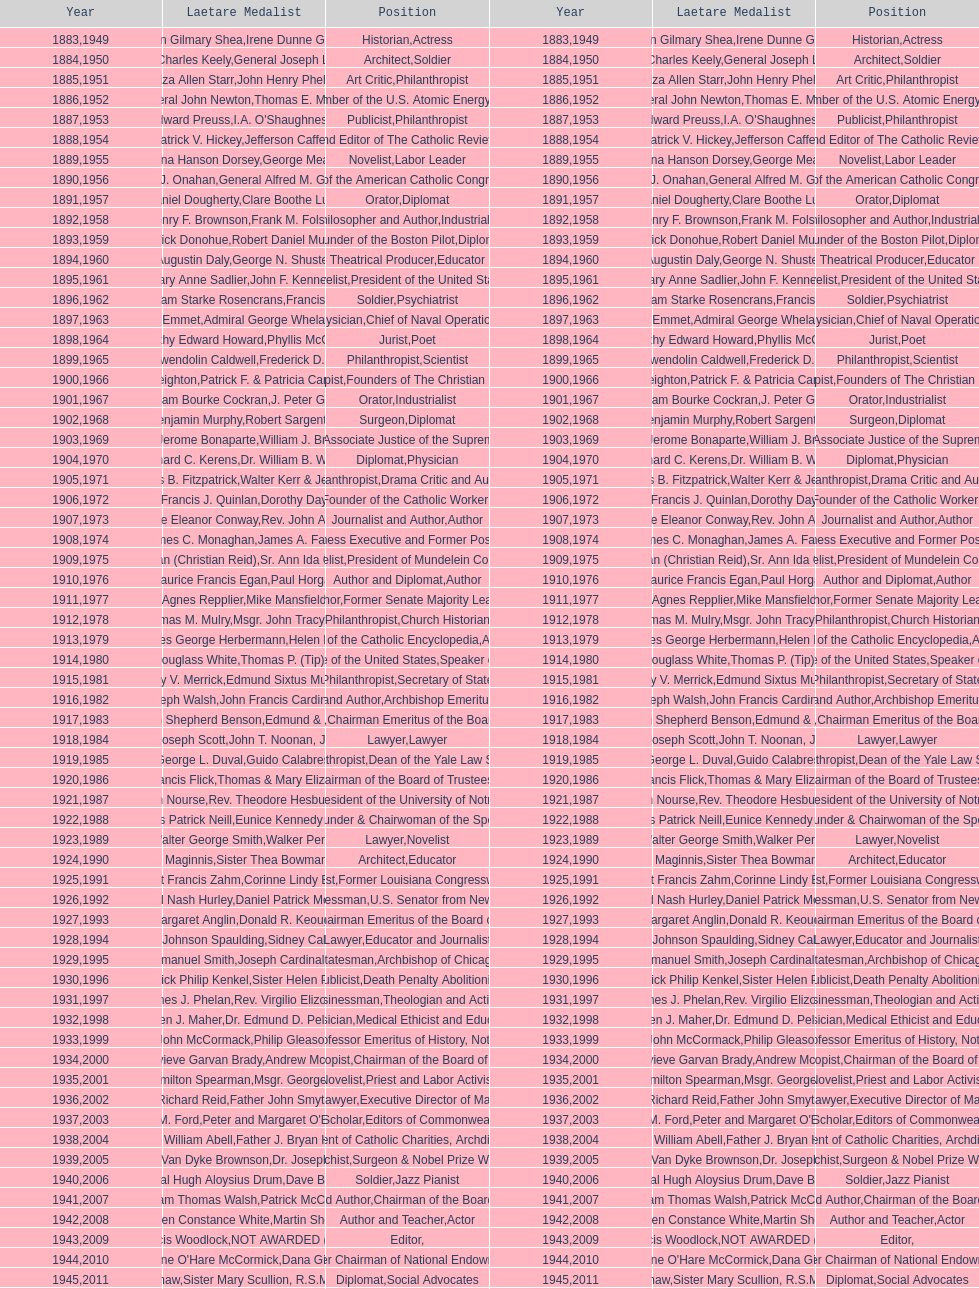Parse the full table. {'header': ['Year', 'Laetare Medalist', 'Position', 'Year', 'Laetare Medalist', 'Position'], 'rows': [['1883', 'John Gilmary Shea', 'Historian', '1949', 'Irene Dunne Griffin', 'Actress'], ['1884', 'Patrick Charles Keely', 'Architect', '1950', 'General Joseph L. Collins', 'Soldier'], ['1885', 'Eliza Allen Starr', 'Art Critic', '1951', 'John Henry Phelan', 'Philanthropist'], ['1886', 'General John Newton', 'Engineer', '1952', 'Thomas E. Murray', 'Member of the U.S. Atomic Energy Commission'], ['1887', 'Edward Preuss', 'Publicist', '1953', "I.A. O'Shaughnessy", 'Philanthropist'], ['1888', 'Patrick V. Hickey', 'Founder and Editor of The Catholic Review', '1954', 'Jefferson Caffery', 'Diplomat'], ['1889', 'Anna Hanson Dorsey', 'Novelist', '1955', 'George Meany', 'Labor Leader'], ['1890', 'William J. Onahan', 'Organizer of the American Catholic Congress', '1956', 'General Alfred M. Gruenther', 'Soldier'], ['1891', 'Daniel Dougherty', 'Orator', '1957', 'Clare Boothe Luce', 'Diplomat'], ['1892', 'Henry F. Brownson', 'Philosopher and Author', '1958', 'Frank M. Folsom', 'Industrialist'], ['1893', 'Patrick Donohue', 'Founder of the Boston Pilot', '1959', 'Robert Daniel Murphy', 'Diplomat'], ['1894', 'Augustin Daly', 'Theatrical Producer', '1960', 'George N. Shuster', 'Educator'], ['1895', 'Mary Anne Sadlier', 'Novelist', '1961', 'John F. Kennedy', 'President of the United States'], ['1896', 'General William Starke Rosencrans', 'Soldier', '1962', 'Francis J. Braceland', 'Psychiatrist'], ['1897', 'Thomas Addis Emmet', 'Physician', '1963', 'Admiral George Whelan Anderson, Jr.', 'Chief of Naval Operations'], ['1898', 'Timothy Edward Howard', 'Jurist', '1964', 'Phyllis McGinley', 'Poet'], ['1899', 'Mary Gwendolin Caldwell', 'Philanthropist', '1965', 'Frederick D. Rossini', 'Scientist'], ['1900', 'John A. Creighton', 'Philanthropist', '1966', 'Patrick F. & Patricia Caron Crowley', 'Founders of The Christian Movement'], ['1901', 'William Bourke Cockran', 'Orator', '1967', 'J. Peter Grace', 'Industrialist'], ['1902', 'John Benjamin Murphy', 'Surgeon', '1968', 'Robert Sargent Shriver', 'Diplomat'], ['1903', 'Charles Jerome Bonaparte', 'Lawyer', '1969', 'William J. Brennan Jr.', 'Associate Justice of the Supreme Court'], ['1904', 'Richard C. Kerens', 'Diplomat', '1970', 'Dr. William B. Walsh', 'Physician'], ['1905', 'Thomas B. Fitzpatrick', 'Philanthropist', '1971', 'Walter Kerr & Jean Kerr', 'Drama Critic and Author'], ['1906', 'Francis J. Quinlan', 'Physician', '1972', 'Dorothy Day', 'Founder of the Catholic Worker Movement'], ['1907', 'Katherine Eleanor Conway', 'Journalist and Author', '1973', "Rev. John A. O'Brien", 'Author'], ['1908', 'James C. Monaghan', 'Economist', '1974', 'James A. Farley', 'Business Executive and Former Postmaster General'], ['1909', 'Frances Tieran (Christian Reid)', 'Novelist', '1975', 'Sr. Ann Ida Gannon, BMV', 'President of Mundelein College'], ['1910', 'Maurice Francis Egan', 'Author and Diplomat', '1976', 'Paul Horgan', 'Author'], ['1911', 'Agnes Repplier', 'Author', '1977', 'Mike Mansfield', 'Former Senate Majority Leader'], ['1912', 'Thomas M. Mulry', 'Philanthropist', '1978', 'Msgr. John Tracy Ellis', 'Church Historian'], ['1913', 'Charles George Herbermann', 'Editor of the Catholic Encyclopedia', '1979', 'Helen Hayes', 'Actress'], ['1914', 'Edward Douglass White', 'Chief Justice of the United States', '1980', "Thomas P. (Tip) O'Neill Jr.", 'Speaker of the House'], ['1915', 'Mary V. Merrick', 'Philanthropist', '1981', 'Edmund Sixtus Muskie', 'Secretary of State'], ['1916', 'James Joseph Walsh', 'Physician and Author', '1982', 'John Francis Cardinal Dearden', 'Archbishop Emeritus of Detroit'], ['1917', 'Admiral William Shepherd Benson', 'Chief of Naval Operations', '1983', 'Edmund & Evelyn Stephan', 'Chairman Emeritus of the Board of Trustees and his wife'], ['1918', 'Joseph Scott', 'Lawyer', '1984', 'John T. Noonan, Jr.', 'Lawyer'], ['1919', 'George L. Duval', 'Philanthropist', '1985', 'Guido Calabresi', 'Dean of the Yale Law School'], ['1920', 'Lawrence Francis Flick', 'Physician', '1986', 'Thomas & Mary Elizabeth Carney', 'Chairman of the Board of Trustees and his wife'], ['1921', 'Elizabeth Nourse', 'Artist', '1987', 'Rev. Theodore Hesburgh, CSC', 'President of the University of Notre Dame'], ['1922', 'Charles Patrick Neill', 'Economist', '1988', 'Eunice Kennedy Shriver', 'Founder & Chairwoman of the Special Olympics'], ['1923', 'Walter George Smith', 'Lawyer', '1989', 'Walker Percy', 'Novelist'], ['1924', 'Charles Donagh Maginnis', 'Architect', '1990', 'Sister Thea Bowman (posthumously)', 'Educator'], ['1925', 'Albert Francis Zahm', 'Scientist', '1991', 'Corinne Lindy Boggs', 'Former Louisiana Congresswoman'], ['1926', 'Edward Nash Hurley', 'Businessman', '1992', 'Daniel Patrick Moynihan', 'U.S. Senator from New York'], ['1927', 'Margaret Anglin', 'Actress', '1993', 'Donald R. Keough', 'Chairman Emeritus of the Board of Trustees'], ['1928', 'John Johnson Spaulding', 'Lawyer', '1994', 'Sidney Callahan', 'Educator and Journalist'], ['1929', 'Alfred Emmanuel Smith', 'Statesman', '1995', 'Joseph Cardinal Bernardin', 'Archbishop of Chicago'], ['1930', 'Frederick Philip Kenkel', 'Publicist', '1996', 'Sister Helen Prejean', 'Death Penalty Abolitionist'], ['1931', 'James J. Phelan', 'Businessman', '1997', 'Rev. Virgilio Elizondo', 'Theologian and Activist'], ['1932', 'Stephen J. Maher', 'Physician', '1998', 'Dr. Edmund D. Pellegrino', 'Medical Ethicist and Educator'], ['1933', 'John McCormack', 'Artist', '1999', 'Philip Gleason', 'Professor Emeritus of History, Notre Dame'], ['1934', 'Genevieve Garvan Brady', 'Philanthropist', '2000', 'Andrew McKenna', 'Chairman of the Board of Trustees'], ['1935', 'Francis Hamilton Spearman', 'Novelist', '2001', 'Msgr. George G. Higgins', 'Priest and Labor Activist'], ['1936', 'Richard Reid', 'Journalist and Lawyer', '2002', 'Father John Smyth', 'Executive Director of Maryville Academy'], ['1937', 'Jeremiah D. M. Ford', 'Scholar', '2003', "Peter and Margaret O'Brien Steinfels", 'Editors of Commonweal'], ['1938', 'Irvin William Abell', 'Surgeon', '2004', 'Father J. Bryan Hehir', 'President of Catholic Charities, Archdiocese of Boston'], ['1939', 'Josephine Van Dyke Brownson', 'Catechist', '2005', 'Dr. Joseph E. Murray', 'Surgeon & Nobel Prize Winner'], ['1940', 'General Hugh Aloysius Drum', 'Soldier', '2006', 'Dave Brubeck', 'Jazz Pianist'], ['1941', 'William Thomas Walsh', 'Journalist and Author', '2007', 'Patrick McCartan', 'Chairman of the Board of Trustees'], ['1942', 'Helen Constance White', 'Author and Teacher', '2008', 'Martin Sheen', 'Actor'], ['1943', 'Thomas Francis Woodlock', 'Editor', '2009', 'NOT AWARDED (SEE BELOW)', ''], ['1944', "Anne O'Hare McCormick", 'Journalist', '2010', 'Dana Gioia', 'Former Chairman of National Endowment for the Arts'], ['1945', 'Gardiner Howland Shaw', 'Diplomat', '2011', 'Sister Mary Scullion, R.S.M., & Joan McConnon', 'Social Advocates'], ['1946', 'Carlton J. H. Hayes', 'Historian and Diplomat', '2012', 'Ken Hackett', 'Former President of Catholic Relief Services'], ['1947', 'William G. Bruce', 'Publisher and Civic Leader', '2013', 'Sister Susanne Gallagher, S.P.\\nSister Mary Therese Harrington, S.H.\\nRev. James H. McCarthy', 'Founders of S.P.R.E.D. (Special Religious Education Development Network)'], ['1948', 'Frank C. Walker', 'Postmaster General and Civic Leader', '2014', 'Kenneth R. Miller', 'Professor of Biology at Brown University']]} How many persons are or were correspondents? 5. 